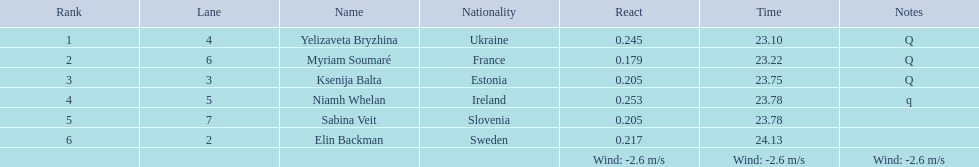What are the names of all individuals involved? Yelizaveta Bryzhina, Myriam Soumaré, Ksenija Balta, Niamh Whelan, Sabina Veit, Elin Backman. What times did they finish? 23.10, 23.22, 23.75, 23.78, 23.78, 24.13. Additionally, what time did ellen backman achieve? 24.13. 